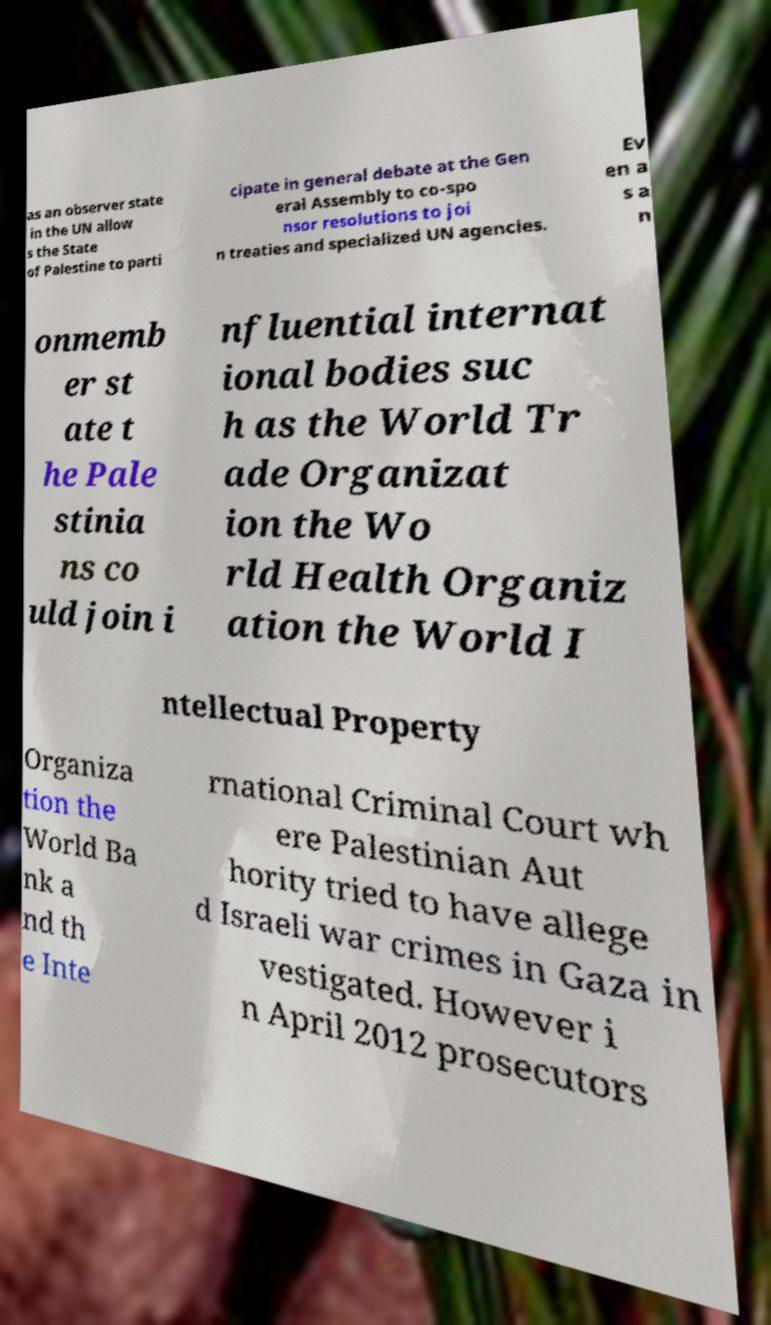There's text embedded in this image that I need extracted. Can you transcribe it verbatim? as an observer state in the UN allow s the State of Palestine to parti cipate in general debate at the Gen eral Assembly to co-spo nsor resolutions to joi n treaties and specialized UN agencies. Ev en a s a n onmemb er st ate t he Pale stinia ns co uld join i nfluential internat ional bodies suc h as the World Tr ade Organizat ion the Wo rld Health Organiz ation the World I ntellectual Property Organiza tion the World Ba nk a nd th e Inte rnational Criminal Court wh ere Palestinian Aut hority tried to have allege d Israeli war crimes in Gaza in vestigated. However i n April 2012 prosecutors 